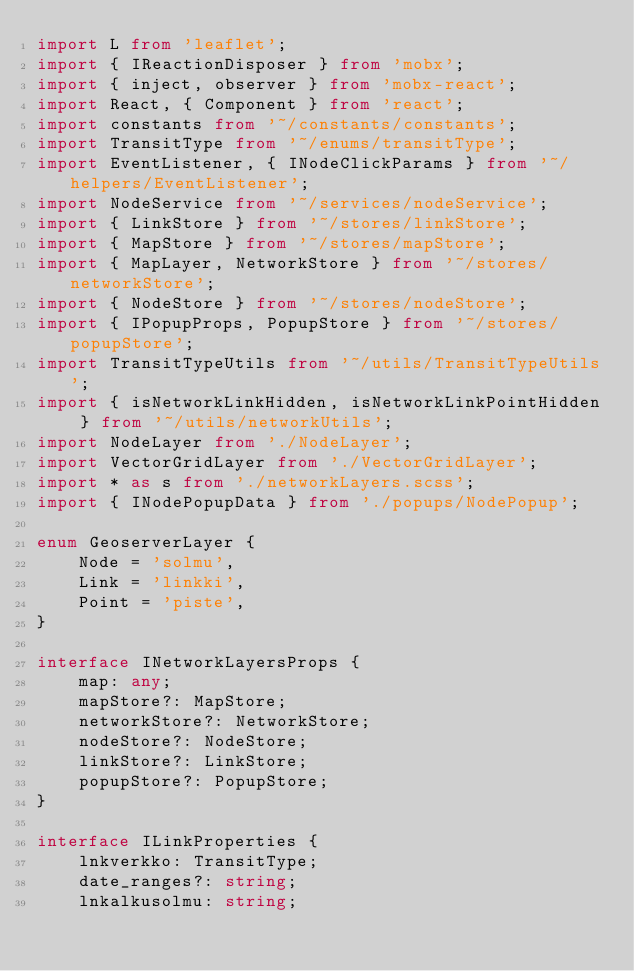<code> <loc_0><loc_0><loc_500><loc_500><_TypeScript_>import L from 'leaflet';
import { IReactionDisposer } from 'mobx';
import { inject, observer } from 'mobx-react';
import React, { Component } from 'react';
import constants from '~/constants/constants';
import TransitType from '~/enums/transitType';
import EventListener, { INodeClickParams } from '~/helpers/EventListener';
import NodeService from '~/services/nodeService';
import { LinkStore } from '~/stores/linkStore';
import { MapStore } from '~/stores/mapStore';
import { MapLayer, NetworkStore } from '~/stores/networkStore';
import { NodeStore } from '~/stores/nodeStore';
import { IPopupProps, PopupStore } from '~/stores/popupStore';
import TransitTypeUtils from '~/utils/TransitTypeUtils';
import { isNetworkLinkHidden, isNetworkLinkPointHidden } from '~/utils/networkUtils';
import NodeLayer from './NodeLayer';
import VectorGridLayer from './VectorGridLayer';
import * as s from './networkLayers.scss';
import { INodePopupData } from './popups/NodePopup';

enum GeoserverLayer {
    Node = 'solmu',
    Link = 'linkki',
    Point = 'piste',
}

interface INetworkLayersProps {
    map: any;
    mapStore?: MapStore;
    networkStore?: NetworkStore;
    nodeStore?: NodeStore;
    linkStore?: LinkStore;
    popupStore?: PopupStore;
}

interface ILinkProperties {
    lnkverkko: TransitType;
    date_ranges?: string;
    lnkalkusolmu: string;</code> 